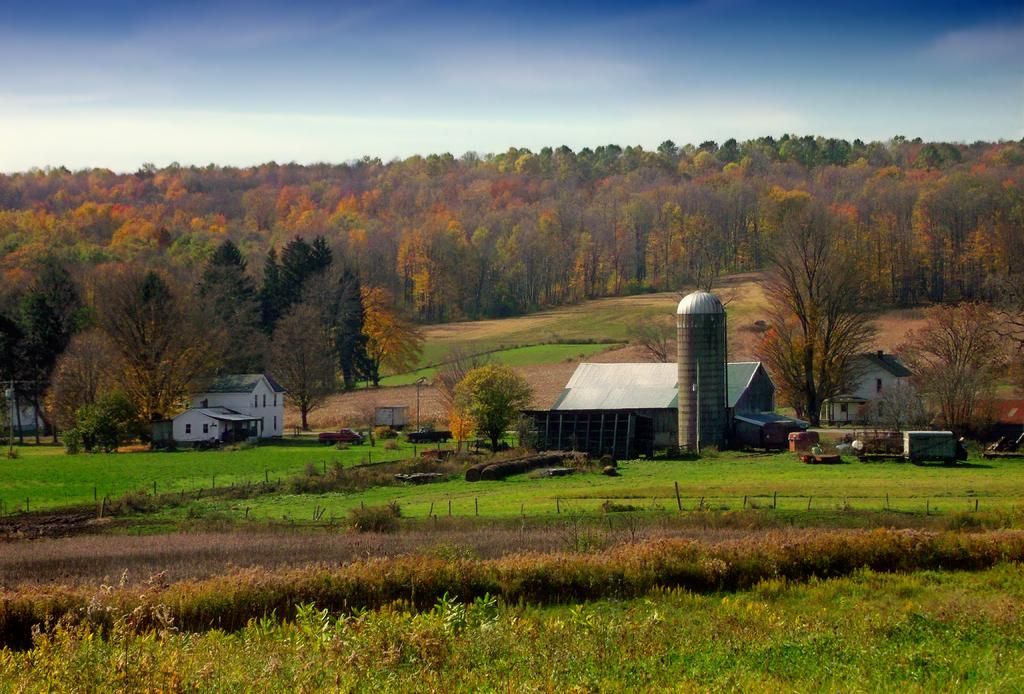What type of vegetation can be seen in the image? There are plants and trees in the image. What is on the ground in the image? There is grass on the ground in the image. What type of structures are present in the image? There are houses in the image. What else can be seen moving in the image? There are vehicles in the image. Are there any other objects visible in the image? Yes, there are some objects in the image. What can be seen in the background of the image? The sky is visible in the background of the image. Can you tell me how many memories are stored in the image? There are no memories present in the image; it is a visual representation of a scene. What type of animals can be seen at the zoo in the image? There is no zoo present in the image, so it is not possible to determine what type of animals might be seen there. 